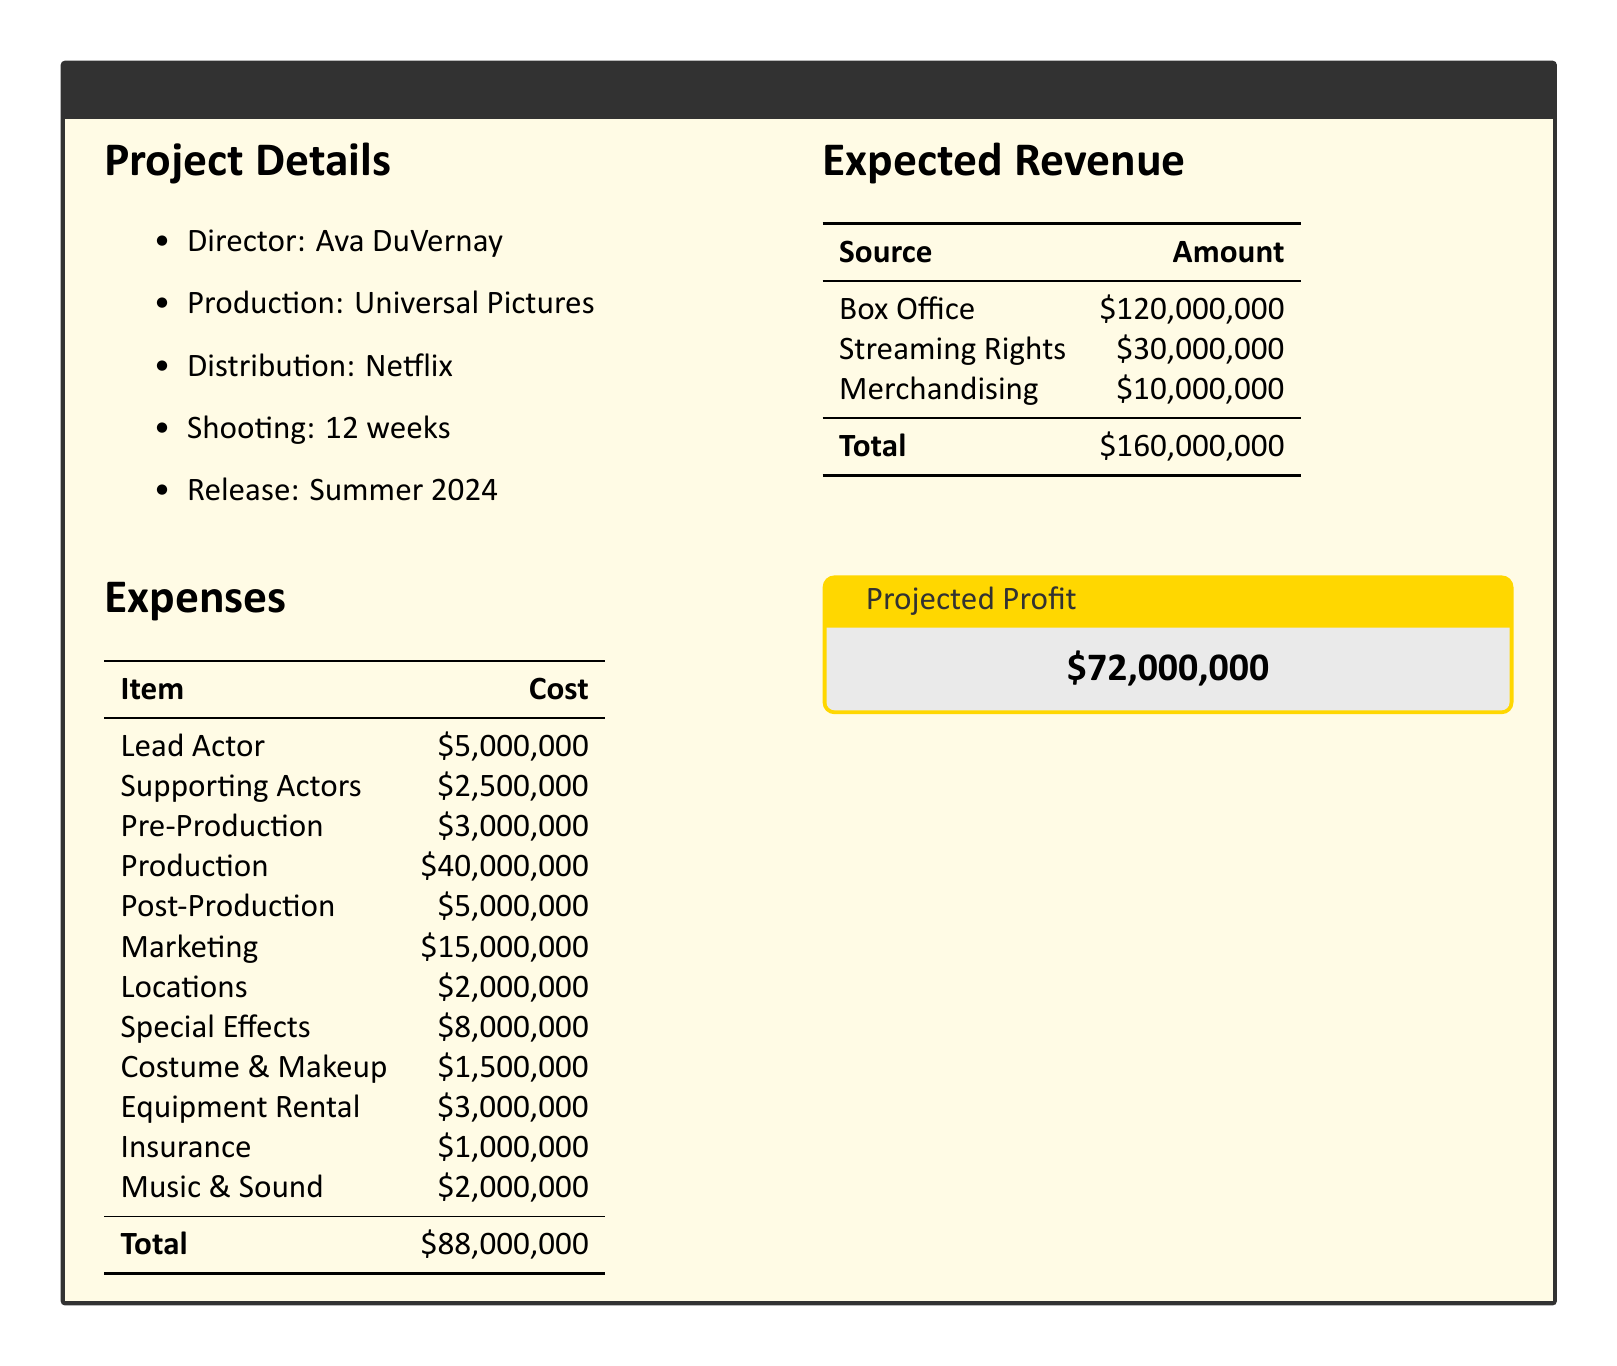What is the total budget for the film? The total budget for the film is provided in the expenses section of the document, which sums up to $88,000,000.
Answer: $88,000,000 Who is the director of the film? The director's name is mentioned in the project details section of the document.
Answer: Ava DuVernay What are the costs associated with special effects? The document lists the cost of special effects under the expenses section as $8,000,000.
Answer: $8,000,000 What is the expected revenue from box office sales? The expected revenue from the box office is indicated in the expected revenue section as $120,000,000.
Answer: $120,000,000 How much will be spent on marketing? The marketing cost is specified in the expenses section and totals $15,000,000.
Answer: $15,000,000 What is the projected profit for the film? The projected profit is stated in a separate highlighted box within the document and calculated as total revenue minus total expenses.
Answer: $72,000,000 What is the total amount expected from streaming rights? The expected revenue from streaming rights is detailed in the document and amounts to $30,000,000.
Answer: $30,000,000 How long is the shooting schedule for the film? The shooting duration is indicated in the project details and is stated as 12 weeks.
Answer: 12 weeks 